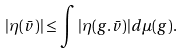<formula> <loc_0><loc_0><loc_500><loc_500>| \eta ( \bar { v } ) | \leq \int | \eta ( g . \bar { v } ) | d \mu ( g ) .</formula> 